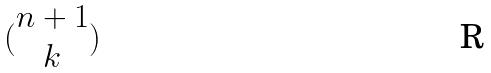Convert formula to latex. <formula><loc_0><loc_0><loc_500><loc_500>( \begin{matrix} n + 1 \\ k \end{matrix} )</formula> 